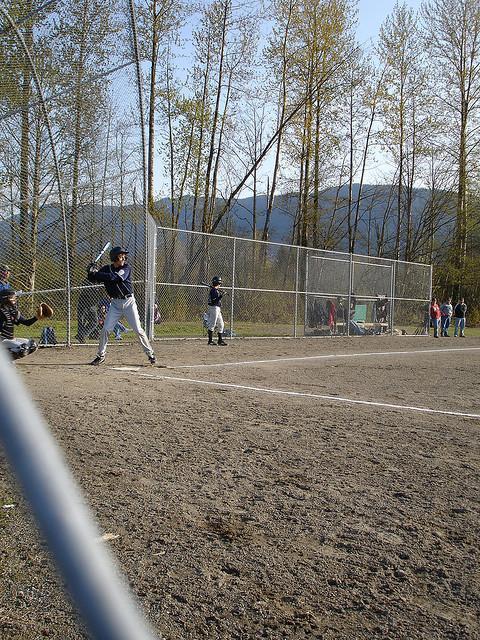What shape is the object used to play this game?
Choose the correct response and explain in the format: 'Answer: answer
Rationale: rationale.'
Options: Oval, disk, oblong, round. Answer: round.
Rationale: The ball is round. 